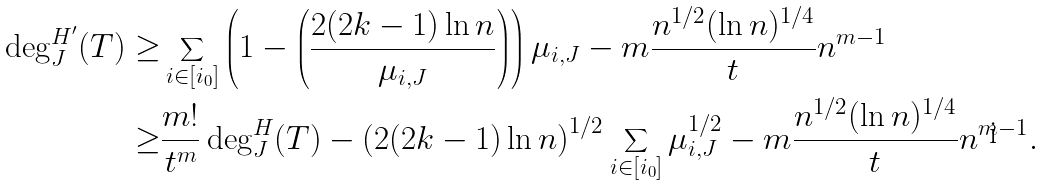<formula> <loc_0><loc_0><loc_500><loc_500>\deg _ { J } ^ { H ^ { \prime } } ( T ) \geq & \sum _ { i \in [ i _ { 0 } ] } \left ( 1 - \left ( \frac { 2 ( 2 k - 1 ) \ln n } { \mu _ { i , J } } \right ) \right ) \mu _ { i , J } - m \frac { n ^ { 1 / 2 } ( \ln n ) ^ { 1 / 4 } } t n ^ { m - 1 } \\ \geq & \frac { m ! } { t ^ { m } } \deg ^ { H } _ { J } ( T ) - \left ( 2 ( 2 k - 1 ) \ln n \right ) ^ { 1 / 2 } \sum _ { i \in [ i _ { 0 } ] } \mu _ { i , J } ^ { 1 / 2 } - m \frac { n ^ { 1 / 2 } ( \ln n ) ^ { 1 / 4 } } t n ^ { m - 1 } .</formula> 